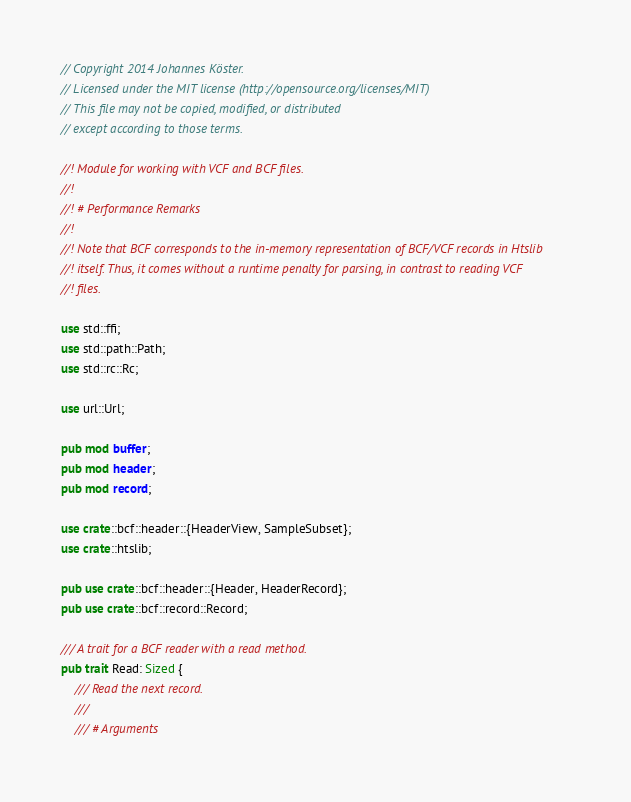<code> <loc_0><loc_0><loc_500><loc_500><_Rust_>// Copyright 2014 Johannes Köster.
// Licensed under the MIT license (http://opensource.org/licenses/MIT)
// This file may not be copied, modified, or distributed
// except according to those terms.

//! Module for working with VCF and BCF files.
//!
//! # Performance Remarks
//!
//! Note that BCF corresponds to the in-memory representation of BCF/VCF records in Htslib
//! itself. Thus, it comes without a runtime penalty for parsing, in contrast to reading VCF
//! files.

use std::ffi;
use std::path::Path;
use std::rc::Rc;

use url::Url;

pub mod buffer;
pub mod header;
pub mod record;

use crate::bcf::header::{HeaderView, SampleSubset};
use crate::htslib;

pub use crate::bcf::header::{Header, HeaderRecord};
pub use crate::bcf::record::Record;

/// A trait for a BCF reader with a read method.
pub trait Read: Sized {
    /// Read the next record.
    ///
    /// # Arguments</code> 